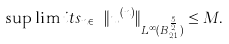<formula> <loc_0><loc_0><loc_500><loc_500>\sup \lim i t s _ { n \in \mathbb { N } } \| u ^ { ( n ) } \| _ { L ^ { \infty } _ { T } ( B ^ { \frac { 5 } { 2 } } _ { 2 , 1 } ) } \leq M .</formula> 